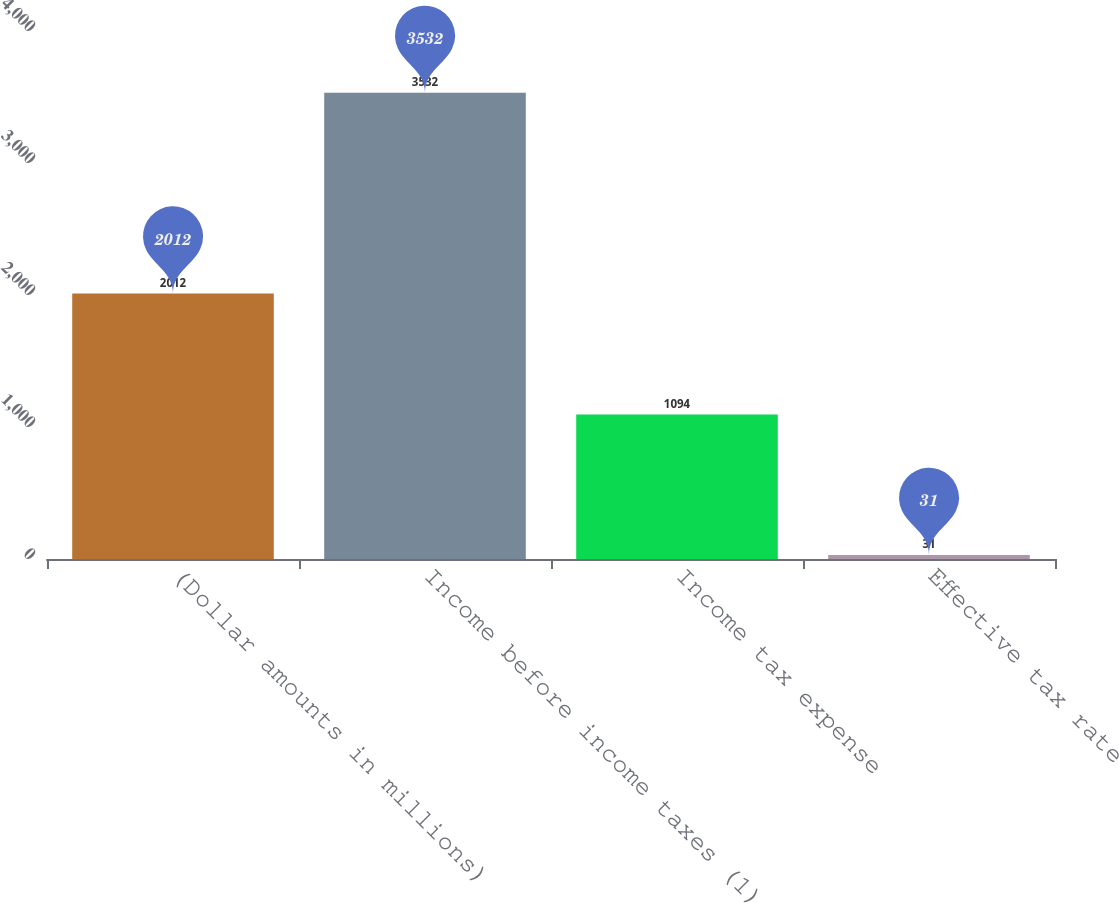Convert chart. <chart><loc_0><loc_0><loc_500><loc_500><bar_chart><fcel>(Dollar amounts in millions)<fcel>Income before income taxes (1)<fcel>Income tax expense<fcel>Effective tax rate<nl><fcel>2012<fcel>3532<fcel>1094<fcel>31<nl></chart> 